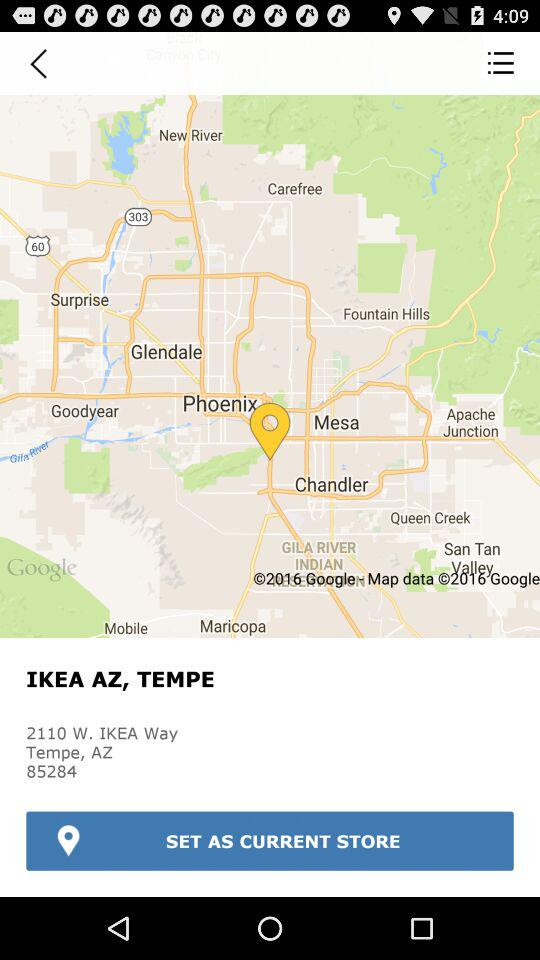What is the Zip code? The Zip code is 85284. 